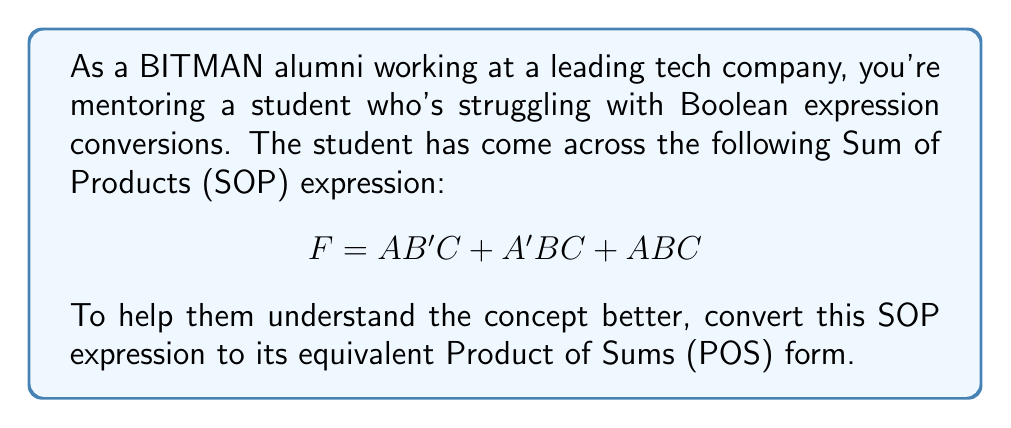Can you answer this question? Let's convert the given SOP expression to POS form step by step:

1) First, we need to find the minterms of the given function. The minterms are:
   $m_5 (101)$, $m_3 (011)$, and $m_7 (111)$

2) To convert to POS, we need to find the maxterms. The maxterms are the complement of the minterms. So, we need all other possible combinations:
   $M_0 (000)$, $M_1 (001)$, $M_2 (010)$, $M_4 (100)$, $M_6 (110)$

3) Now, we can write the POS expression using these maxterms:
   $$ F = M_0 \cdot M_1 \cdot M_2 \cdot M_4 \cdot M_6 $$

4) Let's expand each maxterm:
   $M_0 = (A + B + C)$
   $M_1 = (A + B + C')$
   $M_2 = (A + B' + C)$
   $M_4 = (A' + B + C)$
   $M_6 = (A' + B' + C)$

5) Therefore, the final POS expression is:
   $$ F = (A + B + C)(A + B + C')(A + B' + C)(A' + B + C)(A' + B' + C) $$

This is the equivalent POS form of the given SOP expression.
Answer: $$ F = (A + B + C)(A + B + C')(A + B' + C)(A' + B + C)(A' + B' + C) $$ 